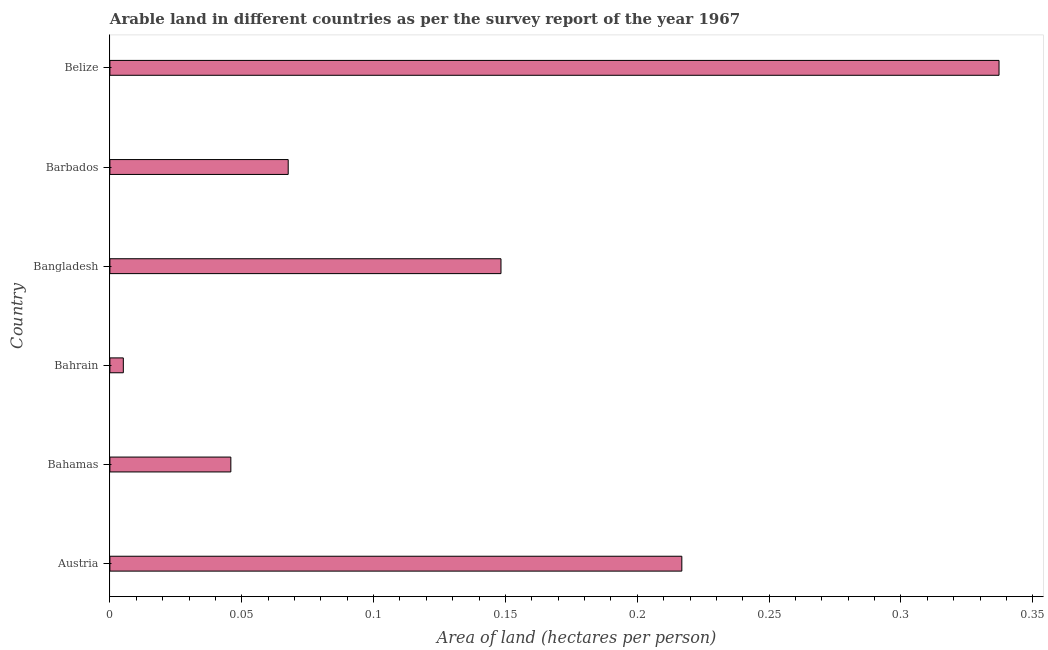Does the graph contain any zero values?
Your response must be concise. No. What is the title of the graph?
Offer a terse response. Arable land in different countries as per the survey report of the year 1967. What is the label or title of the X-axis?
Provide a short and direct response. Area of land (hectares per person). What is the label or title of the Y-axis?
Offer a very short reply. Country. What is the area of arable land in Austria?
Provide a short and direct response. 0.22. Across all countries, what is the maximum area of arable land?
Give a very brief answer. 0.34. Across all countries, what is the minimum area of arable land?
Keep it short and to the point. 0.01. In which country was the area of arable land maximum?
Provide a short and direct response. Belize. In which country was the area of arable land minimum?
Make the answer very short. Bahrain. What is the sum of the area of arable land?
Make the answer very short. 0.82. What is the difference between the area of arable land in Austria and Barbados?
Keep it short and to the point. 0.15. What is the average area of arable land per country?
Offer a very short reply. 0.14. What is the median area of arable land?
Ensure brevity in your answer.  0.11. What is the ratio of the area of arable land in Austria to that in Bahamas?
Ensure brevity in your answer.  4.73. Is the area of arable land in Bahrain less than that in Barbados?
Your response must be concise. Yes. Is the difference between the area of arable land in Bahamas and Bahrain greater than the difference between any two countries?
Offer a very short reply. No. What is the difference between the highest and the second highest area of arable land?
Provide a short and direct response. 0.12. Is the sum of the area of arable land in Austria and Bahamas greater than the maximum area of arable land across all countries?
Offer a very short reply. No. What is the difference between the highest and the lowest area of arable land?
Offer a very short reply. 0.33. What is the difference between two consecutive major ticks on the X-axis?
Your answer should be compact. 0.05. Are the values on the major ticks of X-axis written in scientific E-notation?
Provide a succinct answer. No. What is the Area of land (hectares per person) in Austria?
Your response must be concise. 0.22. What is the Area of land (hectares per person) in Bahamas?
Your response must be concise. 0.05. What is the Area of land (hectares per person) in Bahrain?
Your answer should be very brief. 0.01. What is the Area of land (hectares per person) in Bangladesh?
Make the answer very short. 0.15. What is the Area of land (hectares per person) in Barbados?
Your answer should be compact. 0.07. What is the Area of land (hectares per person) of Belize?
Make the answer very short. 0.34. What is the difference between the Area of land (hectares per person) in Austria and Bahamas?
Keep it short and to the point. 0.17. What is the difference between the Area of land (hectares per person) in Austria and Bahrain?
Your answer should be compact. 0.21. What is the difference between the Area of land (hectares per person) in Austria and Bangladesh?
Give a very brief answer. 0.07. What is the difference between the Area of land (hectares per person) in Austria and Barbados?
Offer a very short reply. 0.15. What is the difference between the Area of land (hectares per person) in Austria and Belize?
Offer a terse response. -0.12. What is the difference between the Area of land (hectares per person) in Bahamas and Bahrain?
Your response must be concise. 0.04. What is the difference between the Area of land (hectares per person) in Bahamas and Bangladesh?
Provide a short and direct response. -0.1. What is the difference between the Area of land (hectares per person) in Bahamas and Barbados?
Ensure brevity in your answer.  -0.02. What is the difference between the Area of land (hectares per person) in Bahamas and Belize?
Make the answer very short. -0.29. What is the difference between the Area of land (hectares per person) in Bahrain and Bangladesh?
Your answer should be very brief. -0.14. What is the difference between the Area of land (hectares per person) in Bahrain and Barbados?
Give a very brief answer. -0.06. What is the difference between the Area of land (hectares per person) in Bahrain and Belize?
Provide a short and direct response. -0.33. What is the difference between the Area of land (hectares per person) in Bangladesh and Barbados?
Offer a terse response. 0.08. What is the difference between the Area of land (hectares per person) in Bangladesh and Belize?
Your answer should be very brief. -0.19. What is the difference between the Area of land (hectares per person) in Barbados and Belize?
Your response must be concise. -0.27. What is the ratio of the Area of land (hectares per person) in Austria to that in Bahamas?
Give a very brief answer. 4.73. What is the ratio of the Area of land (hectares per person) in Austria to that in Bahrain?
Give a very brief answer. 42.55. What is the ratio of the Area of land (hectares per person) in Austria to that in Bangladesh?
Your response must be concise. 1.46. What is the ratio of the Area of land (hectares per person) in Austria to that in Barbados?
Give a very brief answer. 3.21. What is the ratio of the Area of land (hectares per person) in Austria to that in Belize?
Give a very brief answer. 0.64. What is the ratio of the Area of land (hectares per person) in Bahamas to that in Bangladesh?
Offer a very short reply. 0.31. What is the ratio of the Area of land (hectares per person) in Bahamas to that in Barbados?
Offer a very short reply. 0.68. What is the ratio of the Area of land (hectares per person) in Bahamas to that in Belize?
Your answer should be very brief. 0.14. What is the ratio of the Area of land (hectares per person) in Bahrain to that in Bangladesh?
Your answer should be compact. 0.03. What is the ratio of the Area of land (hectares per person) in Bahrain to that in Barbados?
Provide a succinct answer. 0.07. What is the ratio of the Area of land (hectares per person) in Bahrain to that in Belize?
Give a very brief answer. 0.01. What is the ratio of the Area of land (hectares per person) in Bangladesh to that in Barbados?
Keep it short and to the point. 2.19. What is the ratio of the Area of land (hectares per person) in Bangladesh to that in Belize?
Ensure brevity in your answer.  0.44. What is the ratio of the Area of land (hectares per person) in Barbados to that in Belize?
Make the answer very short. 0.2. 